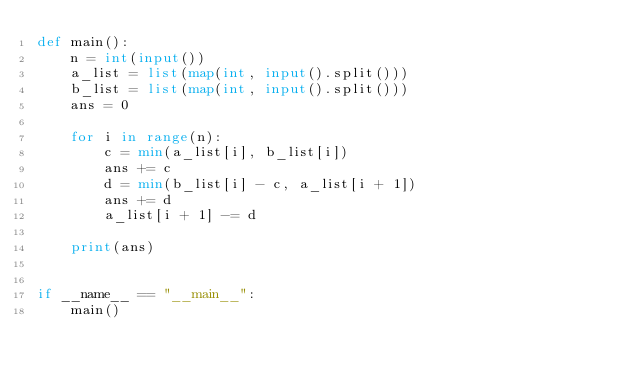<code> <loc_0><loc_0><loc_500><loc_500><_Python_>def main():
    n = int(input())
    a_list = list(map(int, input().split()))
    b_list = list(map(int, input().split()))
    ans = 0

    for i in range(n):
        c = min(a_list[i], b_list[i])
        ans += c
        d = min(b_list[i] - c, a_list[i + 1])
        ans += d
        a_list[i + 1] -= d

    print(ans)


if __name__ == "__main__":
    main()
</code> 